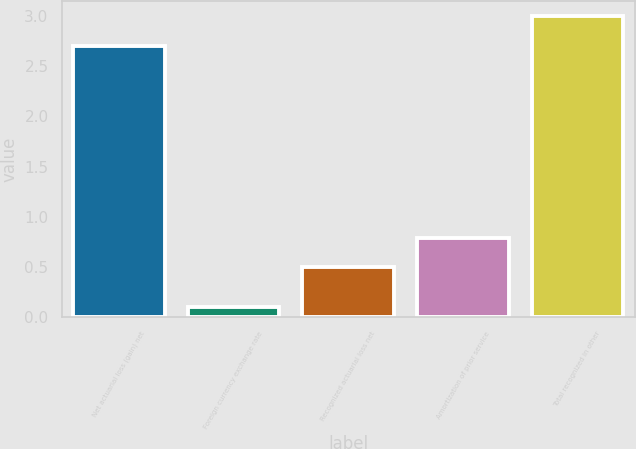Convert chart. <chart><loc_0><loc_0><loc_500><loc_500><bar_chart><fcel>Net actuarial loss (gain) net<fcel>Foreign currency exchange rate<fcel>Recognized actuarial loss net<fcel>Amortization of prior service<fcel>Total recognized in other<nl><fcel>2.7<fcel>0.1<fcel>0.5<fcel>0.79<fcel>3<nl></chart> 